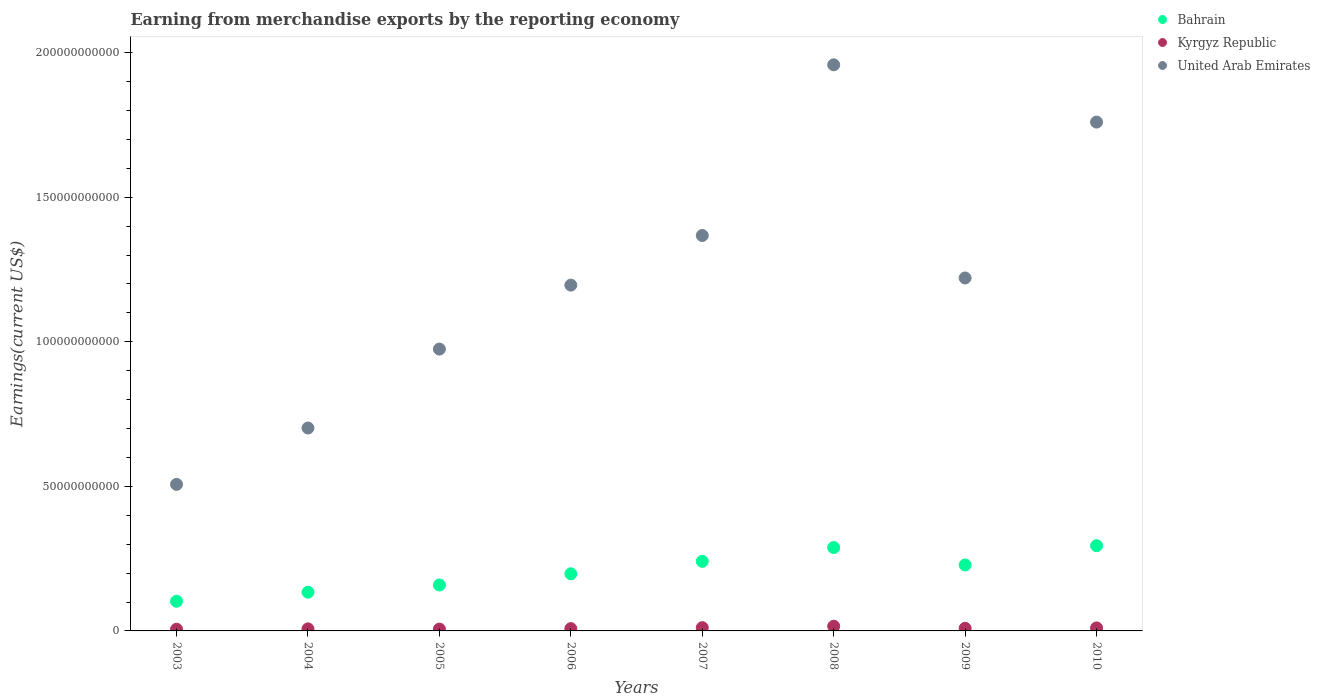How many different coloured dotlines are there?
Provide a succinct answer. 3. What is the amount earned from merchandise exports in United Arab Emirates in 2008?
Offer a very short reply. 1.96e+11. Across all years, what is the maximum amount earned from merchandise exports in Bahrain?
Make the answer very short. 2.95e+1. Across all years, what is the minimum amount earned from merchandise exports in United Arab Emirates?
Make the answer very short. 5.07e+1. What is the total amount earned from merchandise exports in Bahrain in the graph?
Make the answer very short. 1.65e+11. What is the difference between the amount earned from merchandise exports in Kyrgyz Republic in 2005 and that in 2010?
Keep it short and to the point. -4.09e+08. What is the difference between the amount earned from merchandise exports in Kyrgyz Republic in 2009 and the amount earned from merchandise exports in Bahrain in 2007?
Provide a short and direct response. -2.32e+1. What is the average amount earned from merchandise exports in Kyrgyz Republic per year?
Provide a short and direct response. 9.27e+08. In the year 2009, what is the difference between the amount earned from merchandise exports in Kyrgyz Republic and amount earned from merchandise exports in United Arab Emirates?
Provide a succinct answer. -1.21e+11. In how many years, is the amount earned from merchandise exports in United Arab Emirates greater than 90000000000 US$?
Ensure brevity in your answer.  6. What is the ratio of the amount earned from merchandise exports in United Arab Emirates in 2004 to that in 2005?
Provide a succinct answer. 0.72. Is the amount earned from merchandise exports in Kyrgyz Republic in 2006 less than that in 2009?
Your response must be concise. Yes. Is the difference between the amount earned from merchandise exports in Kyrgyz Republic in 2004 and 2006 greater than the difference between the amount earned from merchandise exports in United Arab Emirates in 2004 and 2006?
Give a very brief answer. Yes. What is the difference between the highest and the second highest amount earned from merchandise exports in Bahrain?
Your answer should be very brief. 6.50e+08. What is the difference between the highest and the lowest amount earned from merchandise exports in Kyrgyz Republic?
Your answer should be compact. 1.04e+09. Is the sum of the amount earned from merchandise exports in United Arab Emirates in 2003 and 2008 greater than the maximum amount earned from merchandise exports in Bahrain across all years?
Your answer should be very brief. Yes. Is it the case that in every year, the sum of the amount earned from merchandise exports in United Arab Emirates and amount earned from merchandise exports in Bahrain  is greater than the amount earned from merchandise exports in Kyrgyz Republic?
Provide a short and direct response. Yes. Is the amount earned from merchandise exports in United Arab Emirates strictly less than the amount earned from merchandise exports in Kyrgyz Republic over the years?
Your answer should be very brief. No. How many dotlines are there?
Your answer should be very brief. 3. How many years are there in the graph?
Your answer should be very brief. 8. What is the difference between two consecutive major ticks on the Y-axis?
Provide a succinct answer. 5.00e+1. Are the values on the major ticks of Y-axis written in scientific E-notation?
Your answer should be very brief. No. Does the graph contain any zero values?
Keep it short and to the point. No. What is the title of the graph?
Offer a very short reply. Earning from merchandise exports by the reporting economy. Does "Tajikistan" appear as one of the legend labels in the graph?
Give a very brief answer. No. What is the label or title of the X-axis?
Your response must be concise. Years. What is the label or title of the Y-axis?
Your answer should be very brief. Earnings(current US$). What is the Earnings(current US$) of Bahrain in 2003?
Your response must be concise. 1.03e+1. What is the Earnings(current US$) in Kyrgyz Republic in 2003?
Your response must be concise. 5.81e+08. What is the Earnings(current US$) in United Arab Emirates in 2003?
Your answer should be compact. 5.07e+1. What is the Earnings(current US$) in Bahrain in 2004?
Provide a short and direct response. 1.34e+1. What is the Earnings(current US$) in Kyrgyz Republic in 2004?
Offer a terse response. 7.05e+08. What is the Earnings(current US$) of United Arab Emirates in 2004?
Provide a short and direct response. 7.02e+1. What is the Earnings(current US$) of Bahrain in 2005?
Give a very brief answer. 1.59e+1. What is the Earnings(current US$) in Kyrgyz Republic in 2005?
Offer a very short reply. 6.34e+08. What is the Earnings(current US$) in United Arab Emirates in 2005?
Ensure brevity in your answer.  9.75e+1. What is the Earnings(current US$) in Bahrain in 2006?
Offer a terse response. 1.98e+1. What is the Earnings(current US$) in Kyrgyz Republic in 2006?
Keep it short and to the point. 7.96e+08. What is the Earnings(current US$) in United Arab Emirates in 2006?
Ensure brevity in your answer.  1.20e+11. What is the Earnings(current US$) of Bahrain in 2007?
Provide a short and direct response. 2.41e+1. What is the Earnings(current US$) in Kyrgyz Republic in 2007?
Your answer should be compact. 1.13e+09. What is the Earnings(current US$) in United Arab Emirates in 2007?
Keep it short and to the point. 1.37e+11. What is the Earnings(current US$) of Bahrain in 2008?
Keep it short and to the point. 2.88e+1. What is the Earnings(current US$) of Kyrgyz Republic in 2008?
Make the answer very short. 1.62e+09. What is the Earnings(current US$) in United Arab Emirates in 2008?
Keep it short and to the point. 1.96e+11. What is the Earnings(current US$) in Bahrain in 2009?
Provide a short and direct response. 2.28e+1. What is the Earnings(current US$) of Kyrgyz Republic in 2009?
Your answer should be very brief. 9.04e+08. What is the Earnings(current US$) of United Arab Emirates in 2009?
Ensure brevity in your answer.  1.22e+11. What is the Earnings(current US$) in Bahrain in 2010?
Provide a short and direct response. 2.95e+1. What is the Earnings(current US$) of Kyrgyz Republic in 2010?
Your answer should be very brief. 1.04e+09. What is the Earnings(current US$) in United Arab Emirates in 2010?
Your answer should be very brief. 1.76e+11. Across all years, what is the maximum Earnings(current US$) of Bahrain?
Offer a very short reply. 2.95e+1. Across all years, what is the maximum Earnings(current US$) in Kyrgyz Republic?
Provide a succinct answer. 1.62e+09. Across all years, what is the maximum Earnings(current US$) in United Arab Emirates?
Give a very brief answer. 1.96e+11. Across all years, what is the minimum Earnings(current US$) of Bahrain?
Your answer should be compact. 1.03e+1. Across all years, what is the minimum Earnings(current US$) in Kyrgyz Republic?
Give a very brief answer. 5.81e+08. Across all years, what is the minimum Earnings(current US$) in United Arab Emirates?
Your answer should be very brief. 5.07e+1. What is the total Earnings(current US$) in Bahrain in the graph?
Offer a terse response. 1.65e+11. What is the total Earnings(current US$) of Kyrgyz Republic in the graph?
Your answer should be compact. 7.42e+09. What is the total Earnings(current US$) of United Arab Emirates in the graph?
Offer a very short reply. 9.69e+11. What is the difference between the Earnings(current US$) of Bahrain in 2003 and that in 2004?
Give a very brief answer. -3.14e+09. What is the difference between the Earnings(current US$) of Kyrgyz Republic in 2003 and that in 2004?
Your answer should be compact. -1.25e+08. What is the difference between the Earnings(current US$) in United Arab Emirates in 2003 and that in 2004?
Offer a very short reply. -1.95e+1. What is the difference between the Earnings(current US$) in Bahrain in 2003 and that in 2005?
Give a very brief answer. -5.63e+09. What is the difference between the Earnings(current US$) of Kyrgyz Republic in 2003 and that in 2005?
Your answer should be very brief. -5.31e+07. What is the difference between the Earnings(current US$) in United Arab Emirates in 2003 and that in 2005?
Your answer should be very brief. -4.68e+1. What is the difference between the Earnings(current US$) in Bahrain in 2003 and that in 2006?
Make the answer very short. -9.50e+09. What is the difference between the Earnings(current US$) in Kyrgyz Republic in 2003 and that in 2006?
Your answer should be compact. -2.15e+08. What is the difference between the Earnings(current US$) in United Arab Emirates in 2003 and that in 2006?
Keep it short and to the point. -6.89e+1. What is the difference between the Earnings(current US$) of Bahrain in 2003 and that in 2007?
Your answer should be compact. -1.38e+1. What is the difference between the Earnings(current US$) of Kyrgyz Republic in 2003 and that in 2007?
Your answer should be compact. -5.53e+08. What is the difference between the Earnings(current US$) in United Arab Emirates in 2003 and that in 2007?
Your response must be concise. -8.61e+1. What is the difference between the Earnings(current US$) in Bahrain in 2003 and that in 2008?
Make the answer very short. -1.86e+1. What is the difference between the Earnings(current US$) in Kyrgyz Republic in 2003 and that in 2008?
Your answer should be very brief. -1.04e+09. What is the difference between the Earnings(current US$) in United Arab Emirates in 2003 and that in 2008?
Provide a short and direct response. -1.45e+11. What is the difference between the Earnings(current US$) of Bahrain in 2003 and that in 2009?
Your response must be concise. -1.25e+1. What is the difference between the Earnings(current US$) in Kyrgyz Republic in 2003 and that in 2009?
Give a very brief answer. -3.24e+08. What is the difference between the Earnings(current US$) of United Arab Emirates in 2003 and that in 2009?
Ensure brevity in your answer.  -7.14e+1. What is the difference between the Earnings(current US$) of Bahrain in 2003 and that in 2010?
Offer a very short reply. -1.92e+1. What is the difference between the Earnings(current US$) of Kyrgyz Republic in 2003 and that in 2010?
Provide a short and direct response. -4.62e+08. What is the difference between the Earnings(current US$) of United Arab Emirates in 2003 and that in 2010?
Keep it short and to the point. -1.25e+11. What is the difference between the Earnings(current US$) in Bahrain in 2004 and that in 2005?
Ensure brevity in your answer.  -2.49e+09. What is the difference between the Earnings(current US$) in Kyrgyz Republic in 2004 and that in 2005?
Your response must be concise. 7.16e+07. What is the difference between the Earnings(current US$) of United Arab Emirates in 2004 and that in 2005?
Give a very brief answer. -2.73e+1. What is the difference between the Earnings(current US$) in Bahrain in 2004 and that in 2006?
Your answer should be compact. -6.36e+09. What is the difference between the Earnings(current US$) of Kyrgyz Republic in 2004 and that in 2006?
Your answer should be very brief. -9.08e+07. What is the difference between the Earnings(current US$) of United Arab Emirates in 2004 and that in 2006?
Your answer should be very brief. -4.94e+1. What is the difference between the Earnings(current US$) of Bahrain in 2004 and that in 2007?
Your response must be concise. -1.07e+1. What is the difference between the Earnings(current US$) in Kyrgyz Republic in 2004 and that in 2007?
Provide a succinct answer. -4.29e+08. What is the difference between the Earnings(current US$) in United Arab Emirates in 2004 and that in 2007?
Ensure brevity in your answer.  -6.66e+1. What is the difference between the Earnings(current US$) in Bahrain in 2004 and that in 2008?
Ensure brevity in your answer.  -1.54e+1. What is the difference between the Earnings(current US$) of Kyrgyz Republic in 2004 and that in 2008?
Ensure brevity in your answer.  -9.12e+08. What is the difference between the Earnings(current US$) of United Arab Emirates in 2004 and that in 2008?
Your answer should be compact. -1.26e+11. What is the difference between the Earnings(current US$) in Bahrain in 2004 and that in 2009?
Provide a succinct answer. -9.40e+09. What is the difference between the Earnings(current US$) in Kyrgyz Republic in 2004 and that in 2009?
Your answer should be very brief. -1.99e+08. What is the difference between the Earnings(current US$) in United Arab Emirates in 2004 and that in 2009?
Give a very brief answer. -5.19e+1. What is the difference between the Earnings(current US$) in Bahrain in 2004 and that in 2010?
Give a very brief answer. -1.61e+1. What is the difference between the Earnings(current US$) of Kyrgyz Republic in 2004 and that in 2010?
Provide a succinct answer. -3.38e+08. What is the difference between the Earnings(current US$) in United Arab Emirates in 2004 and that in 2010?
Make the answer very short. -1.06e+11. What is the difference between the Earnings(current US$) of Bahrain in 2005 and that in 2006?
Offer a very short reply. -3.87e+09. What is the difference between the Earnings(current US$) in Kyrgyz Republic in 2005 and that in 2006?
Your response must be concise. -1.62e+08. What is the difference between the Earnings(current US$) of United Arab Emirates in 2005 and that in 2006?
Provide a short and direct response. -2.21e+1. What is the difference between the Earnings(current US$) of Bahrain in 2005 and that in 2007?
Give a very brief answer. -8.18e+09. What is the difference between the Earnings(current US$) of Kyrgyz Republic in 2005 and that in 2007?
Your answer should be compact. -5.00e+08. What is the difference between the Earnings(current US$) in United Arab Emirates in 2005 and that in 2007?
Give a very brief answer. -3.93e+1. What is the difference between the Earnings(current US$) in Bahrain in 2005 and that in 2008?
Provide a succinct answer. -1.29e+1. What is the difference between the Earnings(current US$) in Kyrgyz Republic in 2005 and that in 2008?
Ensure brevity in your answer.  -9.84e+08. What is the difference between the Earnings(current US$) of United Arab Emirates in 2005 and that in 2008?
Make the answer very short. -9.83e+1. What is the difference between the Earnings(current US$) in Bahrain in 2005 and that in 2009?
Provide a short and direct response. -6.92e+09. What is the difference between the Earnings(current US$) in Kyrgyz Republic in 2005 and that in 2009?
Keep it short and to the point. -2.71e+08. What is the difference between the Earnings(current US$) in United Arab Emirates in 2005 and that in 2009?
Give a very brief answer. -2.46e+1. What is the difference between the Earnings(current US$) in Bahrain in 2005 and that in 2010?
Offer a very short reply. -1.36e+1. What is the difference between the Earnings(current US$) in Kyrgyz Republic in 2005 and that in 2010?
Offer a terse response. -4.09e+08. What is the difference between the Earnings(current US$) in United Arab Emirates in 2005 and that in 2010?
Provide a short and direct response. -7.85e+1. What is the difference between the Earnings(current US$) in Bahrain in 2006 and that in 2007?
Provide a short and direct response. -4.31e+09. What is the difference between the Earnings(current US$) in Kyrgyz Republic in 2006 and that in 2007?
Provide a succinct answer. -3.38e+08. What is the difference between the Earnings(current US$) in United Arab Emirates in 2006 and that in 2007?
Your answer should be very brief. -1.72e+1. What is the difference between the Earnings(current US$) of Bahrain in 2006 and that in 2008?
Your response must be concise. -9.08e+09. What is the difference between the Earnings(current US$) in Kyrgyz Republic in 2006 and that in 2008?
Your response must be concise. -8.21e+08. What is the difference between the Earnings(current US$) of United Arab Emirates in 2006 and that in 2008?
Your answer should be compact. -7.62e+1. What is the difference between the Earnings(current US$) of Bahrain in 2006 and that in 2009?
Make the answer very short. -3.05e+09. What is the difference between the Earnings(current US$) in Kyrgyz Republic in 2006 and that in 2009?
Provide a short and direct response. -1.08e+08. What is the difference between the Earnings(current US$) in United Arab Emirates in 2006 and that in 2009?
Offer a very short reply. -2.47e+09. What is the difference between the Earnings(current US$) in Bahrain in 2006 and that in 2010?
Provide a short and direct response. -9.73e+09. What is the difference between the Earnings(current US$) in Kyrgyz Republic in 2006 and that in 2010?
Your answer should be very brief. -2.47e+08. What is the difference between the Earnings(current US$) of United Arab Emirates in 2006 and that in 2010?
Keep it short and to the point. -5.64e+1. What is the difference between the Earnings(current US$) in Bahrain in 2007 and that in 2008?
Keep it short and to the point. -4.77e+09. What is the difference between the Earnings(current US$) in Kyrgyz Republic in 2007 and that in 2008?
Make the answer very short. -4.83e+08. What is the difference between the Earnings(current US$) of United Arab Emirates in 2007 and that in 2008?
Provide a succinct answer. -5.90e+1. What is the difference between the Earnings(current US$) of Bahrain in 2007 and that in 2009?
Provide a short and direct response. 1.26e+09. What is the difference between the Earnings(current US$) in Kyrgyz Republic in 2007 and that in 2009?
Your response must be concise. 2.30e+08. What is the difference between the Earnings(current US$) of United Arab Emirates in 2007 and that in 2009?
Your response must be concise. 1.47e+1. What is the difference between the Earnings(current US$) in Bahrain in 2007 and that in 2010?
Provide a succinct answer. -5.42e+09. What is the difference between the Earnings(current US$) of Kyrgyz Republic in 2007 and that in 2010?
Ensure brevity in your answer.  9.11e+07. What is the difference between the Earnings(current US$) of United Arab Emirates in 2007 and that in 2010?
Your answer should be very brief. -3.92e+1. What is the difference between the Earnings(current US$) in Bahrain in 2008 and that in 2009?
Your response must be concise. 6.03e+09. What is the difference between the Earnings(current US$) in Kyrgyz Republic in 2008 and that in 2009?
Provide a succinct answer. 7.13e+08. What is the difference between the Earnings(current US$) in United Arab Emirates in 2008 and that in 2009?
Provide a succinct answer. 7.37e+1. What is the difference between the Earnings(current US$) of Bahrain in 2008 and that in 2010?
Give a very brief answer. -6.50e+08. What is the difference between the Earnings(current US$) of Kyrgyz Republic in 2008 and that in 2010?
Provide a succinct answer. 5.74e+08. What is the difference between the Earnings(current US$) of United Arab Emirates in 2008 and that in 2010?
Give a very brief answer. 1.98e+1. What is the difference between the Earnings(current US$) of Bahrain in 2009 and that in 2010?
Provide a short and direct response. -6.68e+09. What is the difference between the Earnings(current US$) of Kyrgyz Republic in 2009 and that in 2010?
Your response must be concise. -1.39e+08. What is the difference between the Earnings(current US$) of United Arab Emirates in 2009 and that in 2010?
Offer a terse response. -5.39e+1. What is the difference between the Earnings(current US$) in Bahrain in 2003 and the Earnings(current US$) in Kyrgyz Republic in 2004?
Your answer should be very brief. 9.56e+09. What is the difference between the Earnings(current US$) in Bahrain in 2003 and the Earnings(current US$) in United Arab Emirates in 2004?
Give a very brief answer. -5.99e+1. What is the difference between the Earnings(current US$) of Kyrgyz Republic in 2003 and the Earnings(current US$) of United Arab Emirates in 2004?
Provide a succinct answer. -6.96e+1. What is the difference between the Earnings(current US$) of Bahrain in 2003 and the Earnings(current US$) of Kyrgyz Republic in 2005?
Provide a succinct answer. 9.63e+09. What is the difference between the Earnings(current US$) of Bahrain in 2003 and the Earnings(current US$) of United Arab Emirates in 2005?
Give a very brief answer. -8.72e+1. What is the difference between the Earnings(current US$) of Kyrgyz Republic in 2003 and the Earnings(current US$) of United Arab Emirates in 2005?
Keep it short and to the point. -9.69e+1. What is the difference between the Earnings(current US$) of Bahrain in 2003 and the Earnings(current US$) of Kyrgyz Republic in 2006?
Ensure brevity in your answer.  9.46e+09. What is the difference between the Earnings(current US$) in Bahrain in 2003 and the Earnings(current US$) in United Arab Emirates in 2006?
Your answer should be very brief. -1.09e+11. What is the difference between the Earnings(current US$) of Kyrgyz Republic in 2003 and the Earnings(current US$) of United Arab Emirates in 2006?
Keep it short and to the point. -1.19e+11. What is the difference between the Earnings(current US$) of Bahrain in 2003 and the Earnings(current US$) of Kyrgyz Republic in 2007?
Give a very brief answer. 9.13e+09. What is the difference between the Earnings(current US$) of Bahrain in 2003 and the Earnings(current US$) of United Arab Emirates in 2007?
Your answer should be very brief. -1.26e+11. What is the difference between the Earnings(current US$) of Kyrgyz Republic in 2003 and the Earnings(current US$) of United Arab Emirates in 2007?
Keep it short and to the point. -1.36e+11. What is the difference between the Earnings(current US$) of Bahrain in 2003 and the Earnings(current US$) of Kyrgyz Republic in 2008?
Make the answer very short. 8.64e+09. What is the difference between the Earnings(current US$) of Bahrain in 2003 and the Earnings(current US$) of United Arab Emirates in 2008?
Offer a terse response. -1.86e+11. What is the difference between the Earnings(current US$) in Kyrgyz Republic in 2003 and the Earnings(current US$) in United Arab Emirates in 2008?
Make the answer very short. -1.95e+11. What is the difference between the Earnings(current US$) in Bahrain in 2003 and the Earnings(current US$) in Kyrgyz Republic in 2009?
Make the answer very short. 9.36e+09. What is the difference between the Earnings(current US$) of Bahrain in 2003 and the Earnings(current US$) of United Arab Emirates in 2009?
Your response must be concise. -1.12e+11. What is the difference between the Earnings(current US$) in Kyrgyz Republic in 2003 and the Earnings(current US$) in United Arab Emirates in 2009?
Ensure brevity in your answer.  -1.21e+11. What is the difference between the Earnings(current US$) in Bahrain in 2003 and the Earnings(current US$) in Kyrgyz Republic in 2010?
Keep it short and to the point. 9.22e+09. What is the difference between the Earnings(current US$) in Bahrain in 2003 and the Earnings(current US$) in United Arab Emirates in 2010?
Provide a short and direct response. -1.66e+11. What is the difference between the Earnings(current US$) of Kyrgyz Republic in 2003 and the Earnings(current US$) of United Arab Emirates in 2010?
Keep it short and to the point. -1.75e+11. What is the difference between the Earnings(current US$) in Bahrain in 2004 and the Earnings(current US$) in Kyrgyz Republic in 2005?
Your answer should be very brief. 1.28e+1. What is the difference between the Earnings(current US$) in Bahrain in 2004 and the Earnings(current US$) in United Arab Emirates in 2005?
Your answer should be compact. -8.41e+1. What is the difference between the Earnings(current US$) in Kyrgyz Republic in 2004 and the Earnings(current US$) in United Arab Emirates in 2005?
Give a very brief answer. -9.68e+1. What is the difference between the Earnings(current US$) of Bahrain in 2004 and the Earnings(current US$) of Kyrgyz Republic in 2006?
Ensure brevity in your answer.  1.26e+1. What is the difference between the Earnings(current US$) of Bahrain in 2004 and the Earnings(current US$) of United Arab Emirates in 2006?
Offer a very short reply. -1.06e+11. What is the difference between the Earnings(current US$) of Kyrgyz Republic in 2004 and the Earnings(current US$) of United Arab Emirates in 2006?
Provide a short and direct response. -1.19e+11. What is the difference between the Earnings(current US$) in Bahrain in 2004 and the Earnings(current US$) in Kyrgyz Republic in 2007?
Provide a short and direct response. 1.23e+1. What is the difference between the Earnings(current US$) in Bahrain in 2004 and the Earnings(current US$) in United Arab Emirates in 2007?
Offer a very short reply. -1.23e+11. What is the difference between the Earnings(current US$) in Kyrgyz Republic in 2004 and the Earnings(current US$) in United Arab Emirates in 2007?
Ensure brevity in your answer.  -1.36e+11. What is the difference between the Earnings(current US$) in Bahrain in 2004 and the Earnings(current US$) in Kyrgyz Republic in 2008?
Give a very brief answer. 1.18e+1. What is the difference between the Earnings(current US$) of Bahrain in 2004 and the Earnings(current US$) of United Arab Emirates in 2008?
Provide a short and direct response. -1.82e+11. What is the difference between the Earnings(current US$) of Kyrgyz Republic in 2004 and the Earnings(current US$) of United Arab Emirates in 2008?
Provide a short and direct response. -1.95e+11. What is the difference between the Earnings(current US$) in Bahrain in 2004 and the Earnings(current US$) in Kyrgyz Republic in 2009?
Give a very brief answer. 1.25e+1. What is the difference between the Earnings(current US$) of Bahrain in 2004 and the Earnings(current US$) of United Arab Emirates in 2009?
Your answer should be very brief. -1.09e+11. What is the difference between the Earnings(current US$) in Kyrgyz Republic in 2004 and the Earnings(current US$) in United Arab Emirates in 2009?
Your answer should be compact. -1.21e+11. What is the difference between the Earnings(current US$) of Bahrain in 2004 and the Earnings(current US$) of Kyrgyz Republic in 2010?
Give a very brief answer. 1.24e+1. What is the difference between the Earnings(current US$) of Bahrain in 2004 and the Earnings(current US$) of United Arab Emirates in 2010?
Ensure brevity in your answer.  -1.63e+11. What is the difference between the Earnings(current US$) of Kyrgyz Republic in 2004 and the Earnings(current US$) of United Arab Emirates in 2010?
Your answer should be compact. -1.75e+11. What is the difference between the Earnings(current US$) of Bahrain in 2005 and the Earnings(current US$) of Kyrgyz Republic in 2006?
Give a very brief answer. 1.51e+1. What is the difference between the Earnings(current US$) of Bahrain in 2005 and the Earnings(current US$) of United Arab Emirates in 2006?
Your response must be concise. -1.04e+11. What is the difference between the Earnings(current US$) of Kyrgyz Republic in 2005 and the Earnings(current US$) of United Arab Emirates in 2006?
Your answer should be very brief. -1.19e+11. What is the difference between the Earnings(current US$) of Bahrain in 2005 and the Earnings(current US$) of Kyrgyz Republic in 2007?
Ensure brevity in your answer.  1.48e+1. What is the difference between the Earnings(current US$) of Bahrain in 2005 and the Earnings(current US$) of United Arab Emirates in 2007?
Your response must be concise. -1.21e+11. What is the difference between the Earnings(current US$) in Kyrgyz Republic in 2005 and the Earnings(current US$) in United Arab Emirates in 2007?
Provide a short and direct response. -1.36e+11. What is the difference between the Earnings(current US$) in Bahrain in 2005 and the Earnings(current US$) in Kyrgyz Republic in 2008?
Offer a terse response. 1.43e+1. What is the difference between the Earnings(current US$) of Bahrain in 2005 and the Earnings(current US$) of United Arab Emirates in 2008?
Your response must be concise. -1.80e+11. What is the difference between the Earnings(current US$) of Kyrgyz Republic in 2005 and the Earnings(current US$) of United Arab Emirates in 2008?
Ensure brevity in your answer.  -1.95e+11. What is the difference between the Earnings(current US$) in Bahrain in 2005 and the Earnings(current US$) in Kyrgyz Republic in 2009?
Offer a terse response. 1.50e+1. What is the difference between the Earnings(current US$) in Bahrain in 2005 and the Earnings(current US$) in United Arab Emirates in 2009?
Provide a short and direct response. -1.06e+11. What is the difference between the Earnings(current US$) in Kyrgyz Republic in 2005 and the Earnings(current US$) in United Arab Emirates in 2009?
Give a very brief answer. -1.21e+11. What is the difference between the Earnings(current US$) of Bahrain in 2005 and the Earnings(current US$) of Kyrgyz Republic in 2010?
Your answer should be compact. 1.48e+1. What is the difference between the Earnings(current US$) in Bahrain in 2005 and the Earnings(current US$) in United Arab Emirates in 2010?
Provide a succinct answer. -1.60e+11. What is the difference between the Earnings(current US$) of Kyrgyz Republic in 2005 and the Earnings(current US$) of United Arab Emirates in 2010?
Your answer should be very brief. -1.75e+11. What is the difference between the Earnings(current US$) of Bahrain in 2006 and the Earnings(current US$) of Kyrgyz Republic in 2007?
Your answer should be compact. 1.86e+1. What is the difference between the Earnings(current US$) of Bahrain in 2006 and the Earnings(current US$) of United Arab Emirates in 2007?
Make the answer very short. -1.17e+11. What is the difference between the Earnings(current US$) of Kyrgyz Republic in 2006 and the Earnings(current US$) of United Arab Emirates in 2007?
Your answer should be very brief. -1.36e+11. What is the difference between the Earnings(current US$) in Bahrain in 2006 and the Earnings(current US$) in Kyrgyz Republic in 2008?
Your answer should be compact. 1.81e+1. What is the difference between the Earnings(current US$) in Bahrain in 2006 and the Earnings(current US$) in United Arab Emirates in 2008?
Provide a short and direct response. -1.76e+11. What is the difference between the Earnings(current US$) in Kyrgyz Republic in 2006 and the Earnings(current US$) in United Arab Emirates in 2008?
Keep it short and to the point. -1.95e+11. What is the difference between the Earnings(current US$) of Bahrain in 2006 and the Earnings(current US$) of Kyrgyz Republic in 2009?
Provide a short and direct response. 1.89e+1. What is the difference between the Earnings(current US$) in Bahrain in 2006 and the Earnings(current US$) in United Arab Emirates in 2009?
Keep it short and to the point. -1.02e+11. What is the difference between the Earnings(current US$) in Kyrgyz Republic in 2006 and the Earnings(current US$) in United Arab Emirates in 2009?
Provide a succinct answer. -1.21e+11. What is the difference between the Earnings(current US$) of Bahrain in 2006 and the Earnings(current US$) of Kyrgyz Republic in 2010?
Ensure brevity in your answer.  1.87e+1. What is the difference between the Earnings(current US$) in Bahrain in 2006 and the Earnings(current US$) in United Arab Emirates in 2010?
Provide a succinct answer. -1.56e+11. What is the difference between the Earnings(current US$) of Kyrgyz Republic in 2006 and the Earnings(current US$) of United Arab Emirates in 2010?
Make the answer very short. -1.75e+11. What is the difference between the Earnings(current US$) of Bahrain in 2007 and the Earnings(current US$) of Kyrgyz Republic in 2008?
Your answer should be very brief. 2.24e+1. What is the difference between the Earnings(current US$) of Bahrain in 2007 and the Earnings(current US$) of United Arab Emirates in 2008?
Give a very brief answer. -1.72e+11. What is the difference between the Earnings(current US$) in Kyrgyz Republic in 2007 and the Earnings(current US$) in United Arab Emirates in 2008?
Your answer should be compact. -1.95e+11. What is the difference between the Earnings(current US$) of Bahrain in 2007 and the Earnings(current US$) of Kyrgyz Republic in 2009?
Your answer should be very brief. 2.32e+1. What is the difference between the Earnings(current US$) of Bahrain in 2007 and the Earnings(current US$) of United Arab Emirates in 2009?
Provide a short and direct response. -9.80e+1. What is the difference between the Earnings(current US$) of Kyrgyz Republic in 2007 and the Earnings(current US$) of United Arab Emirates in 2009?
Your response must be concise. -1.21e+11. What is the difference between the Earnings(current US$) in Bahrain in 2007 and the Earnings(current US$) in Kyrgyz Republic in 2010?
Provide a short and direct response. 2.30e+1. What is the difference between the Earnings(current US$) of Bahrain in 2007 and the Earnings(current US$) of United Arab Emirates in 2010?
Make the answer very short. -1.52e+11. What is the difference between the Earnings(current US$) in Kyrgyz Republic in 2007 and the Earnings(current US$) in United Arab Emirates in 2010?
Give a very brief answer. -1.75e+11. What is the difference between the Earnings(current US$) in Bahrain in 2008 and the Earnings(current US$) in Kyrgyz Republic in 2009?
Your response must be concise. 2.79e+1. What is the difference between the Earnings(current US$) in Bahrain in 2008 and the Earnings(current US$) in United Arab Emirates in 2009?
Provide a succinct answer. -9.32e+1. What is the difference between the Earnings(current US$) of Kyrgyz Republic in 2008 and the Earnings(current US$) of United Arab Emirates in 2009?
Offer a very short reply. -1.20e+11. What is the difference between the Earnings(current US$) of Bahrain in 2008 and the Earnings(current US$) of Kyrgyz Republic in 2010?
Your response must be concise. 2.78e+1. What is the difference between the Earnings(current US$) in Bahrain in 2008 and the Earnings(current US$) in United Arab Emirates in 2010?
Make the answer very short. -1.47e+11. What is the difference between the Earnings(current US$) in Kyrgyz Republic in 2008 and the Earnings(current US$) in United Arab Emirates in 2010?
Provide a succinct answer. -1.74e+11. What is the difference between the Earnings(current US$) in Bahrain in 2009 and the Earnings(current US$) in Kyrgyz Republic in 2010?
Your answer should be very brief. 2.18e+1. What is the difference between the Earnings(current US$) in Bahrain in 2009 and the Earnings(current US$) in United Arab Emirates in 2010?
Keep it short and to the point. -1.53e+11. What is the difference between the Earnings(current US$) of Kyrgyz Republic in 2009 and the Earnings(current US$) of United Arab Emirates in 2010?
Provide a succinct answer. -1.75e+11. What is the average Earnings(current US$) of Bahrain per year?
Keep it short and to the point. 2.06e+1. What is the average Earnings(current US$) of Kyrgyz Republic per year?
Your answer should be compact. 9.27e+08. What is the average Earnings(current US$) of United Arab Emirates per year?
Give a very brief answer. 1.21e+11. In the year 2003, what is the difference between the Earnings(current US$) in Bahrain and Earnings(current US$) in Kyrgyz Republic?
Provide a succinct answer. 9.68e+09. In the year 2003, what is the difference between the Earnings(current US$) in Bahrain and Earnings(current US$) in United Arab Emirates?
Offer a terse response. -4.04e+1. In the year 2003, what is the difference between the Earnings(current US$) in Kyrgyz Republic and Earnings(current US$) in United Arab Emirates?
Your response must be concise. -5.01e+1. In the year 2004, what is the difference between the Earnings(current US$) of Bahrain and Earnings(current US$) of Kyrgyz Republic?
Provide a succinct answer. 1.27e+1. In the year 2004, what is the difference between the Earnings(current US$) in Bahrain and Earnings(current US$) in United Arab Emirates?
Provide a short and direct response. -5.68e+1. In the year 2004, what is the difference between the Earnings(current US$) in Kyrgyz Republic and Earnings(current US$) in United Arab Emirates?
Offer a very short reply. -6.95e+1. In the year 2005, what is the difference between the Earnings(current US$) in Bahrain and Earnings(current US$) in Kyrgyz Republic?
Offer a very short reply. 1.53e+1. In the year 2005, what is the difference between the Earnings(current US$) of Bahrain and Earnings(current US$) of United Arab Emirates?
Your answer should be very brief. -8.16e+1. In the year 2005, what is the difference between the Earnings(current US$) in Kyrgyz Republic and Earnings(current US$) in United Arab Emirates?
Your answer should be compact. -9.68e+1. In the year 2006, what is the difference between the Earnings(current US$) of Bahrain and Earnings(current US$) of Kyrgyz Republic?
Provide a short and direct response. 1.90e+1. In the year 2006, what is the difference between the Earnings(current US$) in Bahrain and Earnings(current US$) in United Arab Emirates?
Offer a terse response. -9.98e+1. In the year 2006, what is the difference between the Earnings(current US$) in Kyrgyz Republic and Earnings(current US$) in United Arab Emirates?
Offer a very short reply. -1.19e+11. In the year 2007, what is the difference between the Earnings(current US$) of Bahrain and Earnings(current US$) of Kyrgyz Republic?
Your answer should be very brief. 2.29e+1. In the year 2007, what is the difference between the Earnings(current US$) in Bahrain and Earnings(current US$) in United Arab Emirates?
Offer a terse response. -1.13e+11. In the year 2007, what is the difference between the Earnings(current US$) of Kyrgyz Republic and Earnings(current US$) of United Arab Emirates?
Give a very brief answer. -1.36e+11. In the year 2008, what is the difference between the Earnings(current US$) of Bahrain and Earnings(current US$) of Kyrgyz Republic?
Ensure brevity in your answer.  2.72e+1. In the year 2008, what is the difference between the Earnings(current US$) in Bahrain and Earnings(current US$) in United Arab Emirates?
Your response must be concise. -1.67e+11. In the year 2008, what is the difference between the Earnings(current US$) of Kyrgyz Republic and Earnings(current US$) of United Arab Emirates?
Your response must be concise. -1.94e+11. In the year 2009, what is the difference between the Earnings(current US$) in Bahrain and Earnings(current US$) in Kyrgyz Republic?
Offer a very short reply. 2.19e+1. In the year 2009, what is the difference between the Earnings(current US$) of Bahrain and Earnings(current US$) of United Arab Emirates?
Offer a very short reply. -9.93e+1. In the year 2009, what is the difference between the Earnings(current US$) in Kyrgyz Republic and Earnings(current US$) in United Arab Emirates?
Keep it short and to the point. -1.21e+11. In the year 2010, what is the difference between the Earnings(current US$) of Bahrain and Earnings(current US$) of Kyrgyz Republic?
Keep it short and to the point. 2.84e+1. In the year 2010, what is the difference between the Earnings(current US$) in Bahrain and Earnings(current US$) in United Arab Emirates?
Provide a succinct answer. -1.46e+11. In the year 2010, what is the difference between the Earnings(current US$) in Kyrgyz Republic and Earnings(current US$) in United Arab Emirates?
Provide a short and direct response. -1.75e+11. What is the ratio of the Earnings(current US$) of Bahrain in 2003 to that in 2004?
Provide a short and direct response. 0.77. What is the ratio of the Earnings(current US$) of Kyrgyz Republic in 2003 to that in 2004?
Offer a very short reply. 0.82. What is the ratio of the Earnings(current US$) in United Arab Emirates in 2003 to that in 2004?
Offer a very short reply. 0.72. What is the ratio of the Earnings(current US$) of Bahrain in 2003 to that in 2005?
Offer a terse response. 0.65. What is the ratio of the Earnings(current US$) in Kyrgyz Republic in 2003 to that in 2005?
Your answer should be compact. 0.92. What is the ratio of the Earnings(current US$) of United Arab Emirates in 2003 to that in 2005?
Provide a short and direct response. 0.52. What is the ratio of the Earnings(current US$) in Bahrain in 2003 to that in 2006?
Your answer should be compact. 0.52. What is the ratio of the Earnings(current US$) of Kyrgyz Republic in 2003 to that in 2006?
Offer a very short reply. 0.73. What is the ratio of the Earnings(current US$) in United Arab Emirates in 2003 to that in 2006?
Keep it short and to the point. 0.42. What is the ratio of the Earnings(current US$) in Bahrain in 2003 to that in 2007?
Provide a succinct answer. 0.43. What is the ratio of the Earnings(current US$) in Kyrgyz Republic in 2003 to that in 2007?
Provide a succinct answer. 0.51. What is the ratio of the Earnings(current US$) of United Arab Emirates in 2003 to that in 2007?
Keep it short and to the point. 0.37. What is the ratio of the Earnings(current US$) in Bahrain in 2003 to that in 2008?
Make the answer very short. 0.36. What is the ratio of the Earnings(current US$) of Kyrgyz Republic in 2003 to that in 2008?
Your response must be concise. 0.36. What is the ratio of the Earnings(current US$) in United Arab Emirates in 2003 to that in 2008?
Your answer should be compact. 0.26. What is the ratio of the Earnings(current US$) of Bahrain in 2003 to that in 2009?
Ensure brevity in your answer.  0.45. What is the ratio of the Earnings(current US$) of Kyrgyz Republic in 2003 to that in 2009?
Make the answer very short. 0.64. What is the ratio of the Earnings(current US$) in United Arab Emirates in 2003 to that in 2009?
Offer a very short reply. 0.42. What is the ratio of the Earnings(current US$) of Bahrain in 2003 to that in 2010?
Give a very brief answer. 0.35. What is the ratio of the Earnings(current US$) in Kyrgyz Republic in 2003 to that in 2010?
Offer a terse response. 0.56. What is the ratio of the Earnings(current US$) of United Arab Emirates in 2003 to that in 2010?
Offer a terse response. 0.29. What is the ratio of the Earnings(current US$) in Bahrain in 2004 to that in 2005?
Ensure brevity in your answer.  0.84. What is the ratio of the Earnings(current US$) in Kyrgyz Republic in 2004 to that in 2005?
Give a very brief answer. 1.11. What is the ratio of the Earnings(current US$) in United Arab Emirates in 2004 to that in 2005?
Your response must be concise. 0.72. What is the ratio of the Earnings(current US$) of Bahrain in 2004 to that in 2006?
Offer a very short reply. 0.68. What is the ratio of the Earnings(current US$) of Kyrgyz Republic in 2004 to that in 2006?
Provide a succinct answer. 0.89. What is the ratio of the Earnings(current US$) of United Arab Emirates in 2004 to that in 2006?
Your answer should be very brief. 0.59. What is the ratio of the Earnings(current US$) in Bahrain in 2004 to that in 2007?
Offer a terse response. 0.56. What is the ratio of the Earnings(current US$) of Kyrgyz Republic in 2004 to that in 2007?
Your response must be concise. 0.62. What is the ratio of the Earnings(current US$) in United Arab Emirates in 2004 to that in 2007?
Ensure brevity in your answer.  0.51. What is the ratio of the Earnings(current US$) in Bahrain in 2004 to that in 2008?
Provide a short and direct response. 0.46. What is the ratio of the Earnings(current US$) in Kyrgyz Republic in 2004 to that in 2008?
Your response must be concise. 0.44. What is the ratio of the Earnings(current US$) in United Arab Emirates in 2004 to that in 2008?
Your answer should be very brief. 0.36. What is the ratio of the Earnings(current US$) in Bahrain in 2004 to that in 2009?
Give a very brief answer. 0.59. What is the ratio of the Earnings(current US$) of Kyrgyz Republic in 2004 to that in 2009?
Your response must be concise. 0.78. What is the ratio of the Earnings(current US$) of United Arab Emirates in 2004 to that in 2009?
Provide a short and direct response. 0.57. What is the ratio of the Earnings(current US$) in Bahrain in 2004 to that in 2010?
Provide a short and direct response. 0.45. What is the ratio of the Earnings(current US$) in Kyrgyz Republic in 2004 to that in 2010?
Ensure brevity in your answer.  0.68. What is the ratio of the Earnings(current US$) in United Arab Emirates in 2004 to that in 2010?
Give a very brief answer. 0.4. What is the ratio of the Earnings(current US$) of Bahrain in 2005 to that in 2006?
Offer a very short reply. 0.8. What is the ratio of the Earnings(current US$) in Kyrgyz Republic in 2005 to that in 2006?
Ensure brevity in your answer.  0.8. What is the ratio of the Earnings(current US$) of United Arab Emirates in 2005 to that in 2006?
Offer a terse response. 0.82. What is the ratio of the Earnings(current US$) in Bahrain in 2005 to that in 2007?
Offer a terse response. 0.66. What is the ratio of the Earnings(current US$) of Kyrgyz Republic in 2005 to that in 2007?
Your response must be concise. 0.56. What is the ratio of the Earnings(current US$) in United Arab Emirates in 2005 to that in 2007?
Offer a terse response. 0.71. What is the ratio of the Earnings(current US$) in Bahrain in 2005 to that in 2008?
Give a very brief answer. 0.55. What is the ratio of the Earnings(current US$) of Kyrgyz Republic in 2005 to that in 2008?
Make the answer very short. 0.39. What is the ratio of the Earnings(current US$) of United Arab Emirates in 2005 to that in 2008?
Your answer should be very brief. 0.5. What is the ratio of the Earnings(current US$) in Bahrain in 2005 to that in 2009?
Your response must be concise. 0.7. What is the ratio of the Earnings(current US$) of Kyrgyz Republic in 2005 to that in 2009?
Your answer should be compact. 0.7. What is the ratio of the Earnings(current US$) of United Arab Emirates in 2005 to that in 2009?
Provide a short and direct response. 0.8. What is the ratio of the Earnings(current US$) in Bahrain in 2005 to that in 2010?
Your response must be concise. 0.54. What is the ratio of the Earnings(current US$) in Kyrgyz Republic in 2005 to that in 2010?
Your answer should be compact. 0.61. What is the ratio of the Earnings(current US$) in United Arab Emirates in 2005 to that in 2010?
Keep it short and to the point. 0.55. What is the ratio of the Earnings(current US$) in Bahrain in 2006 to that in 2007?
Provide a short and direct response. 0.82. What is the ratio of the Earnings(current US$) in Kyrgyz Republic in 2006 to that in 2007?
Your answer should be very brief. 0.7. What is the ratio of the Earnings(current US$) in United Arab Emirates in 2006 to that in 2007?
Provide a short and direct response. 0.87. What is the ratio of the Earnings(current US$) of Bahrain in 2006 to that in 2008?
Ensure brevity in your answer.  0.69. What is the ratio of the Earnings(current US$) of Kyrgyz Republic in 2006 to that in 2008?
Your response must be concise. 0.49. What is the ratio of the Earnings(current US$) in United Arab Emirates in 2006 to that in 2008?
Offer a terse response. 0.61. What is the ratio of the Earnings(current US$) of Bahrain in 2006 to that in 2009?
Your response must be concise. 0.87. What is the ratio of the Earnings(current US$) in Kyrgyz Republic in 2006 to that in 2009?
Your response must be concise. 0.88. What is the ratio of the Earnings(current US$) in United Arab Emirates in 2006 to that in 2009?
Offer a terse response. 0.98. What is the ratio of the Earnings(current US$) in Bahrain in 2006 to that in 2010?
Your answer should be very brief. 0.67. What is the ratio of the Earnings(current US$) in Kyrgyz Republic in 2006 to that in 2010?
Offer a terse response. 0.76. What is the ratio of the Earnings(current US$) of United Arab Emirates in 2006 to that in 2010?
Give a very brief answer. 0.68. What is the ratio of the Earnings(current US$) of Bahrain in 2007 to that in 2008?
Your answer should be compact. 0.83. What is the ratio of the Earnings(current US$) of Kyrgyz Republic in 2007 to that in 2008?
Your response must be concise. 0.7. What is the ratio of the Earnings(current US$) in United Arab Emirates in 2007 to that in 2008?
Offer a terse response. 0.7. What is the ratio of the Earnings(current US$) in Bahrain in 2007 to that in 2009?
Provide a short and direct response. 1.06. What is the ratio of the Earnings(current US$) of Kyrgyz Republic in 2007 to that in 2009?
Your answer should be compact. 1.25. What is the ratio of the Earnings(current US$) of United Arab Emirates in 2007 to that in 2009?
Make the answer very short. 1.12. What is the ratio of the Earnings(current US$) in Bahrain in 2007 to that in 2010?
Offer a terse response. 0.82. What is the ratio of the Earnings(current US$) of Kyrgyz Republic in 2007 to that in 2010?
Provide a short and direct response. 1.09. What is the ratio of the Earnings(current US$) in United Arab Emirates in 2007 to that in 2010?
Your answer should be compact. 0.78. What is the ratio of the Earnings(current US$) in Bahrain in 2008 to that in 2009?
Your answer should be very brief. 1.26. What is the ratio of the Earnings(current US$) in Kyrgyz Republic in 2008 to that in 2009?
Offer a terse response. 1.79. What is the ratio of the Earnings(current US$) in United Arab Emirates in 2008 to that in 2009?
Offer a terse response. 1.6. What is the ratio of the Earnings(current US$) in Bahrain in 2008 to that in 2010?
Keep it short and to the point. 0.98. What is the ratio of the Earnings(current US$) of Kyrgyz Republic in 2008 to that in 2010?
Provide a succinct answer. 1.55. What is the ratio of the Earnings(current US$) in United Arab Emirates in 2008 to that in 2010?
Keep it short and to the point. 1.11. What is the ratio of the Earnings(current US$) in Bahrain in 2009 to that in 2010?
Provide a short and direct response. 0.77. What is the ratio of the Earnings(current US$) in Kyrgyz Republic in 2009 to that in 2010?
Give a very brief answer. 0.87. What is the ratio of the Earnings(current US$) of United Arab Emirates in 2009 to that in 2010?
Your answer should be compact. 0.69. What is the difference between the highest and the second highest Earnings(current US$) of Bahrain?
Give a very brief answer. 6.50e+08. What is the difference between the highest and the second highest Earnings(current US$) in Kyrgyz Republic?
Offer a very short reply. 4.83e+08. What is the difference between the highest and the second highest Earnings(current US$) of United Arab Emirates?
Provide a succinct answer. 1.98e+1. What is the difference between the highest and the lowest Earnings(current US$) of Bahrain?
Make the answer very short. 1.92e+1. What is the difference between the highest and the lowest Earnings(current US$) in Kyrgyz Republic?
Make the answer very short. 1.04e+09. What is the difference between the highest and the lowest Earnings(current US$) of United Arab Emirates?
Keep it short and to the point. 1.45e+11. 